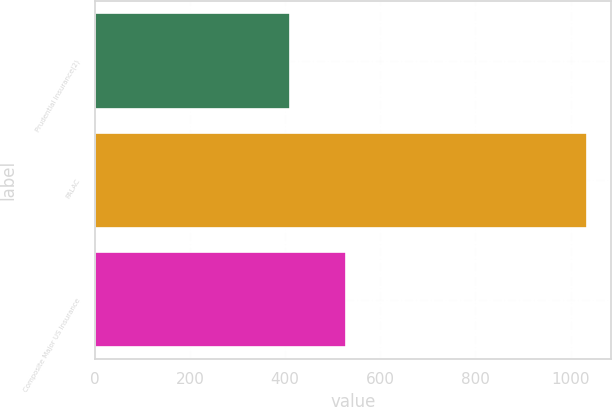<chart> <loc_0><loc_0><loc_500><loc_500><bar_chart><fcel>Prudential Insurance(2)<fcel>PALAC<fcel>Composite Major US Insurance<nl><fcel>410<fcel>1034<fcel>529<nl></chart> 